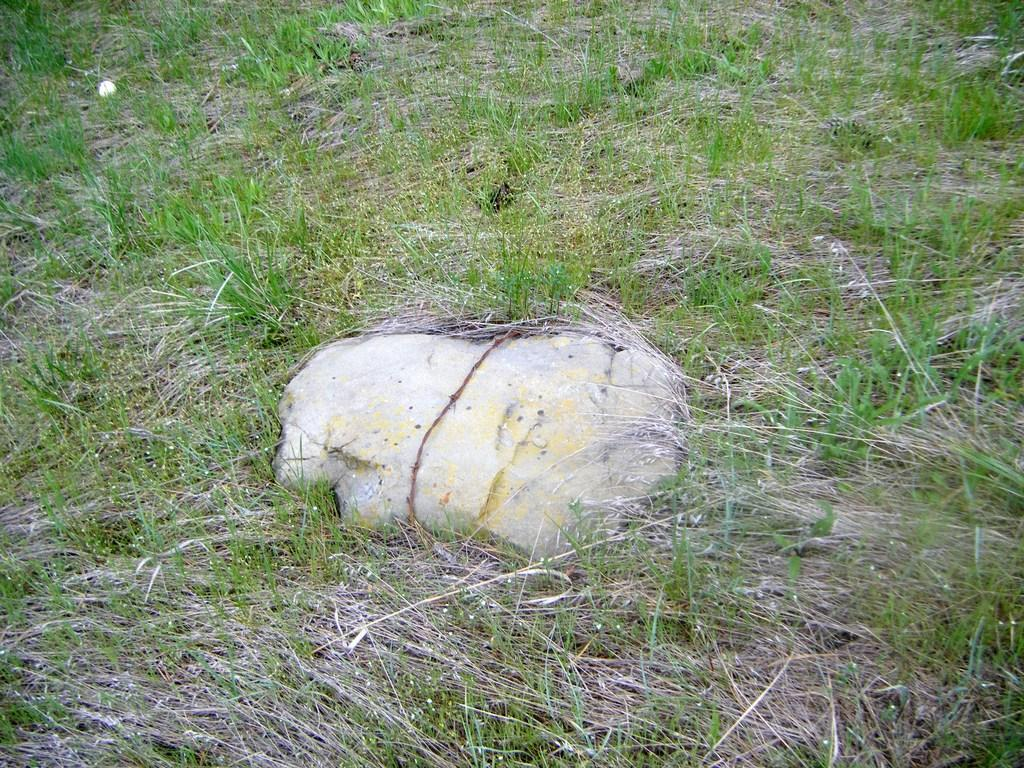What type of vegetation is present in the image? There is grass in the image. What other object can be seen in the image? There is a stone in the image. What type of news can be seen on the stone in the image? There is no news present in the image, as it only features grass and a stone. What type of coil is wrapped around the grass in the image? There is no coil present in the image. 